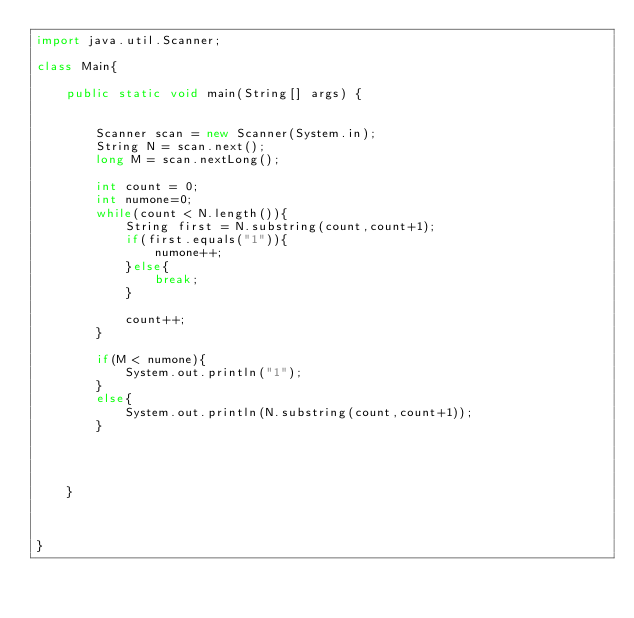<code> <loc_0><loc_0><loc_500><loc_500><_Java_>import java.util.Scanner;

class Main{

	public static void main(String[] args) {


		Scanner scan = new Scanner(System.in);
		String N = scan.next();
		long M = scan.nextLong();

		int count = 0;
		int numone=0;
		while(count < N.length()){
			String first = N.substring(count,count+1);
			if(first.equals("1")){
				numone++;
			}else{
				break;
			}
			
			count++;
		}
		
		if(M < numone){
			System.out.println("1");
		}	
		else{
			System.out.println(N.substring(count,count+1));
		}




	}



}</code> 